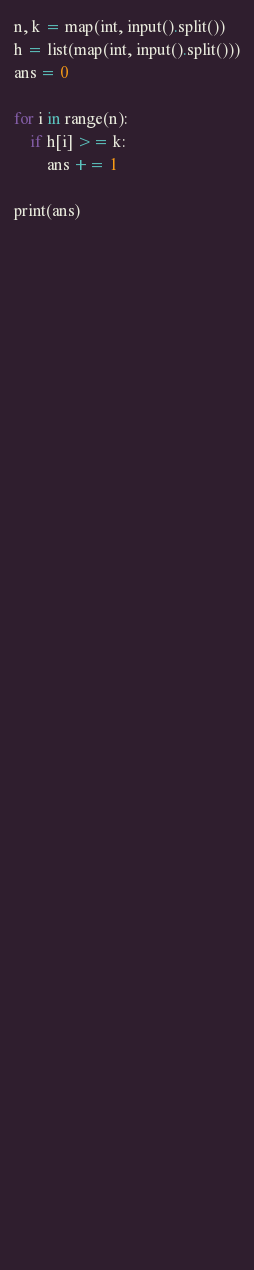<code> <loc_0><loc_0><loc_500><loc_500><_Python_>n, k = map(int, input().split())
h = list(map(int, input().split()))
ans = 0

for i in range(n):
    if h[i] >= k:
        ans += 1

print(ans)



        



    










 

 


                                        




    




        


    







        

</code> 